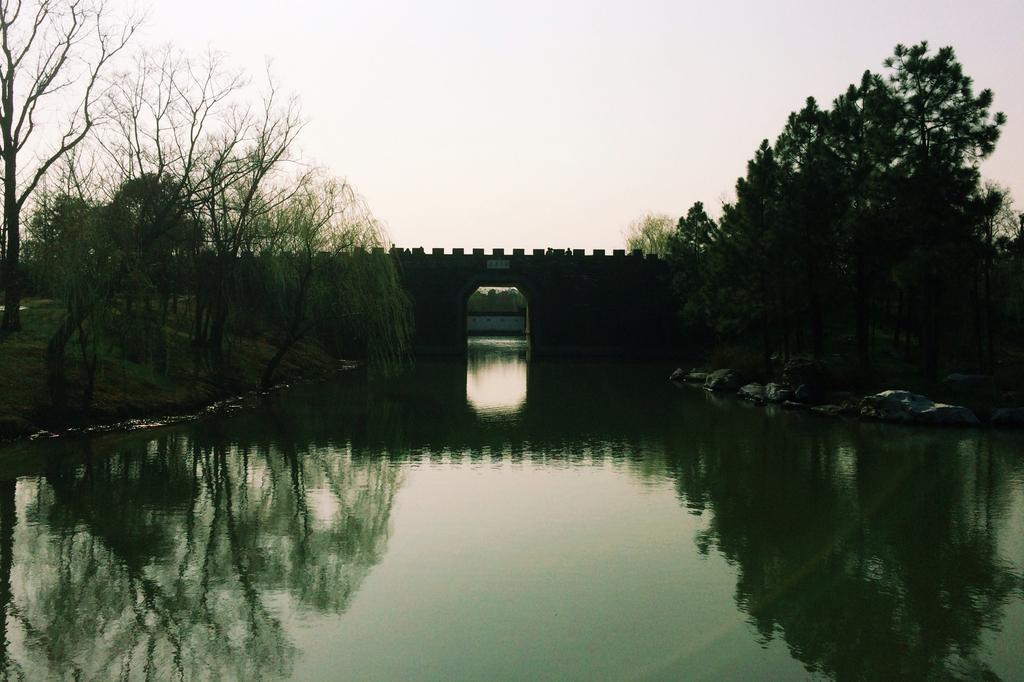Describe this image in one or two sentences. In this image I can see few trees, water, bridge and few rocks. The sky is in white color. 